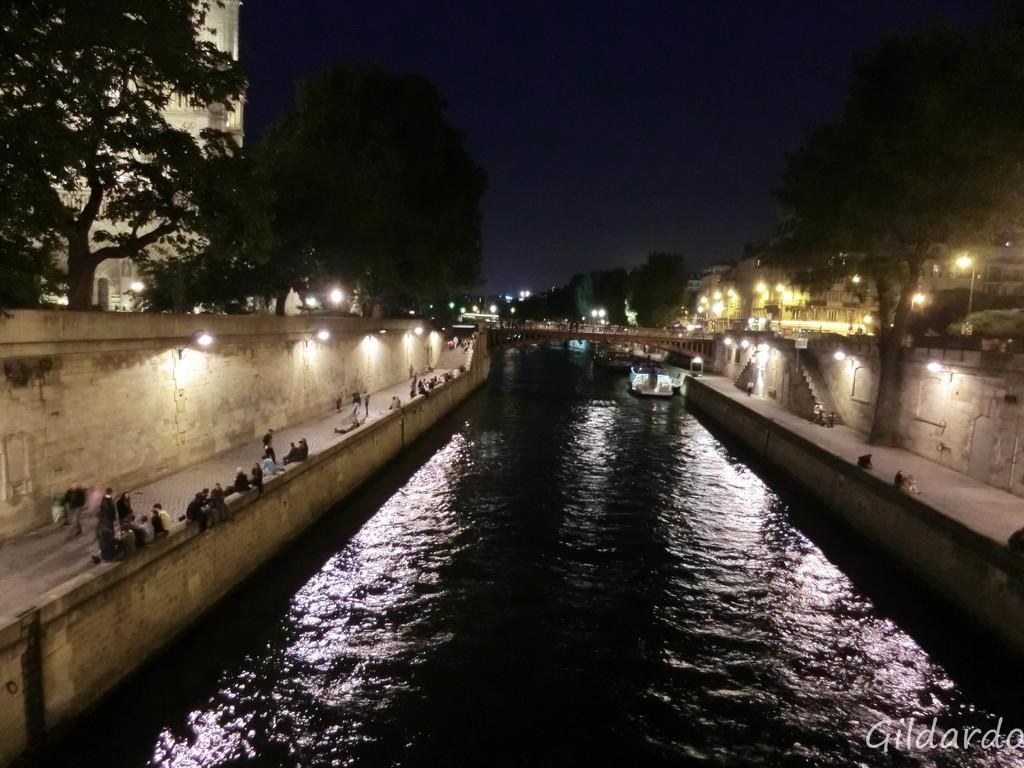Describe this image in one or two sentences. In this image we can see a bridge above the water, there are some trees, poles, lights, people, dogs and staircase, in the background we can see the sky. 